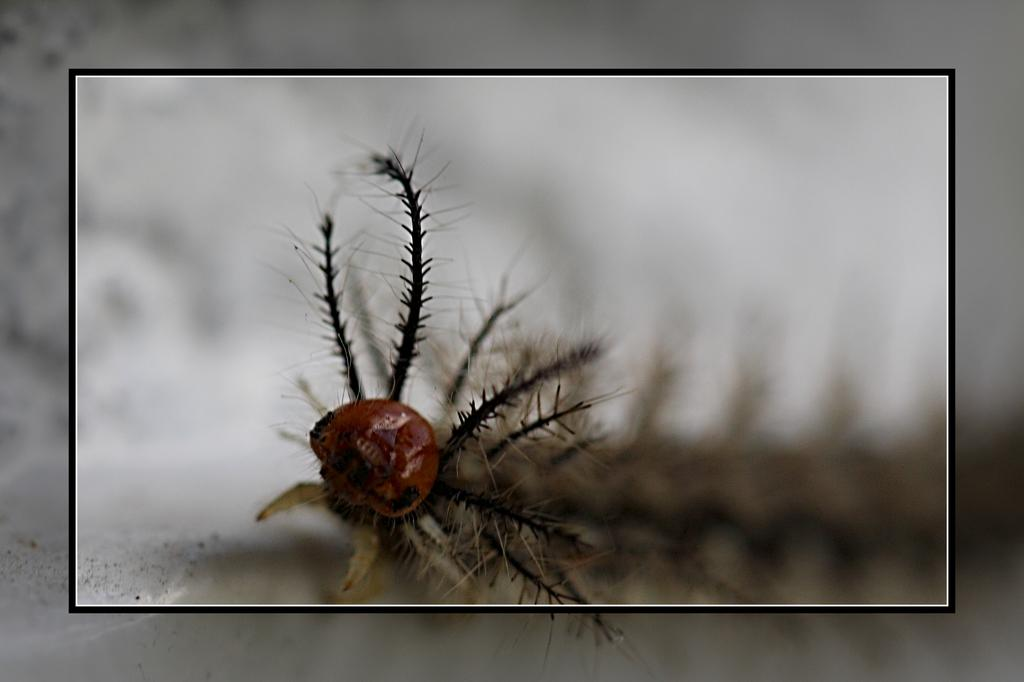What is the main subject of the picture? There is an insect in the picture. Can you describe the background of the picture? The background of the picture is blurred. Is there any additional feature surrounding the picture? Yes, the picture has a frame. What type of line can be seen in the picture? There is no line present in the picture; it features an insect and a blurred background. What act is the insect performing in the picture? The insect is not performing any act in the picture; it is simply present in the image. 